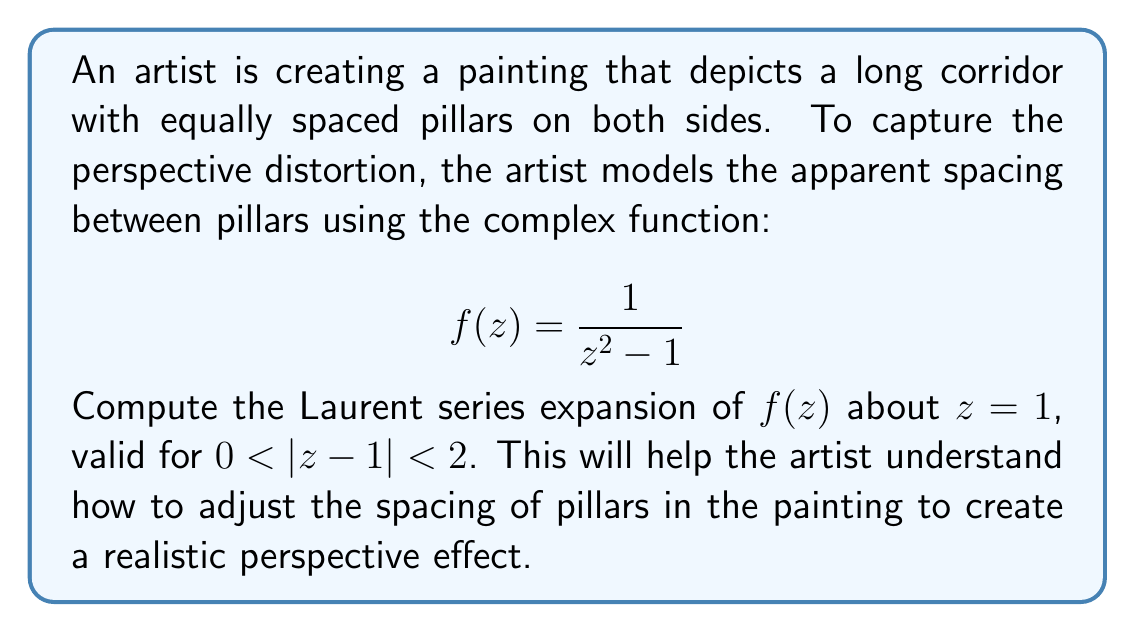Teach me how to tackle this problem. To find the Laurent series expansion of $f(z)$ about $z = 1$, we need to follow these steps:

1) First, we make the substitution $w = z - 1$, so $z = w + 1$. This centers our expansion around $z = 1$.

2) Rewrite the function in terms of $w$:

   $$f(w+1) = \frac{1}{(w+1)^2 - 1} = \frac{1}{w^2 + 2w}$$

3) Factor out $w$ from the denominator:

   $$f(w+1) = \frac{1}{w(w + 2)}$$

4) Use partial fraction decomposition:

   $$\frac{1}{w(w + 2)} = \frac{A}{w} + \frac{B}{w + 2}$$

   Solving for $A$ and $B$, we get $A = -\frac{1}{2}$ and $B = \frac{1}{2}$.

5) So, we have:

   $$f(w+1) = -\frac{1}{2w} + \frac{1}{2(w + 2)}$$

6) For the second term, we can use the geometric series expansion:

   $$\frac{1}{w + 2} = \frac{1}{2} \cdot \frac{1}{1 + \frac{w}{2}} = \frac{1}{2} \sum_{n=0}^{\infty} (-1)^n \left(\frac{w}{2}\right)^n$$

7) Substituting this back:

   $$f(w+1) = -\frac{1}{2w} + \frac{1}{4} \sum_{n=0}^{\infty} (-1)^n \left(\frac{w}{2}\right)^n$$

8) Expanding the sum:

   $$f(w+1) = -\frac{1}{2w} + \frac{1}{4} - \frac{w}{8} + \frac{w^2}{16} - \frac{w^3}{32} + \cdots$$

9) Finally, substitute back $w = z - 1$:

   $$f(z) = -\frac{1}{2(z-1)} + \frac{1}{4} - \frac{z-1}{8} + \frac{(z-1)^2}{16} - \frac{(z-1)^3}{32} + \cdots$$

This Laurent series is valid for $0 < |z-1| < 2$, which corresponds to the original domain of convergence.
Answer: The Laurent series expansion of $f(z) = \frac{1}{z^2 - 1}$ about $z = 1$, valid for $0 < |z-1| < 2$, is:

$$f(z) = -\frac{1}{2(z-1)} + \frac{1}{4} - \frac{z-1}{8} + \frac{(z-1)^2}{16} - \frac{(z-1)^3}{32} + \cdots$$

or more generally:

$$f(z) = -\frac{1}{2(z-1)} + \sum_{n=0}^{\infty} \frac{(-1)^n(z-1)^n}{2^{n+2}}$$ 